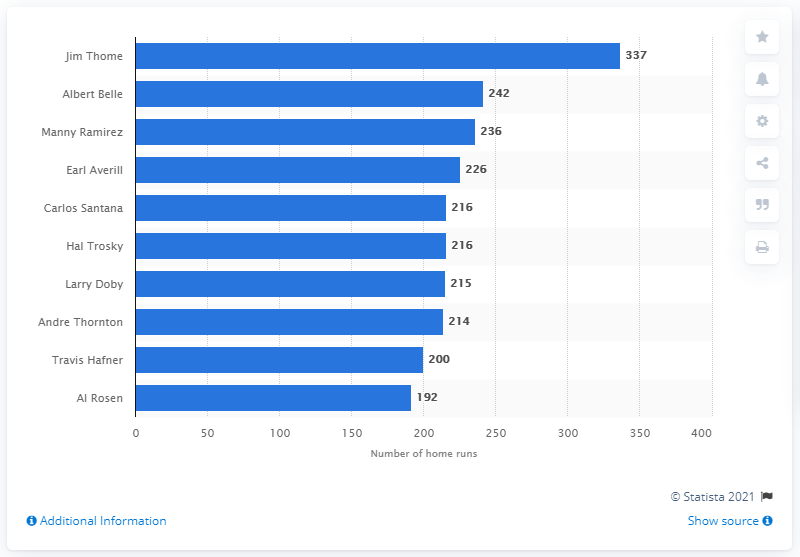Indicate a few pertinent items in this graphic. As of his last season in 2012, Jim Thome had hit a total of 612 home runs, making him one of the greatest home run hitters in the history of Major League Baseball. The Cleveland Indians franchise has seen many talented baseball players throughout its history, but none have hit more home runs than Jim Thome. His impressive record of home run hitting during his time with the Indians has cemented his place in team history as the player who has hit the most home runs. 